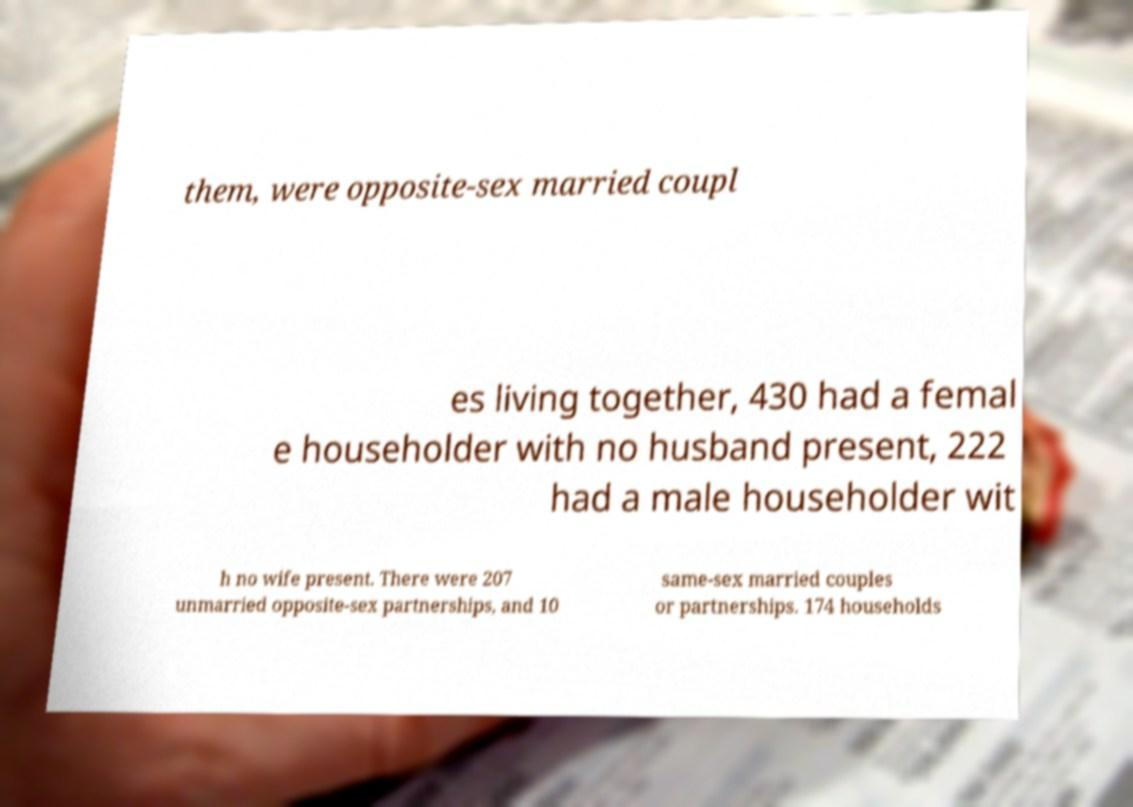I need the written content from this picture converted into text. Can you do that? them, were opposite-sex married coupl es living together, 430 had a femal e householder with no husband present, 222 had a male householder wit h no wife present. There were 207 unmarried opposite-sex partnerships, and 10 same-sex married couples or partnerships. 174 households 